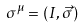Convert formula to latex. <formula><loc_0><loc_0><loc_500><loc_500>\sigma ^ { \mu } = ( I , { \vec { \sigma } } )</formula> 